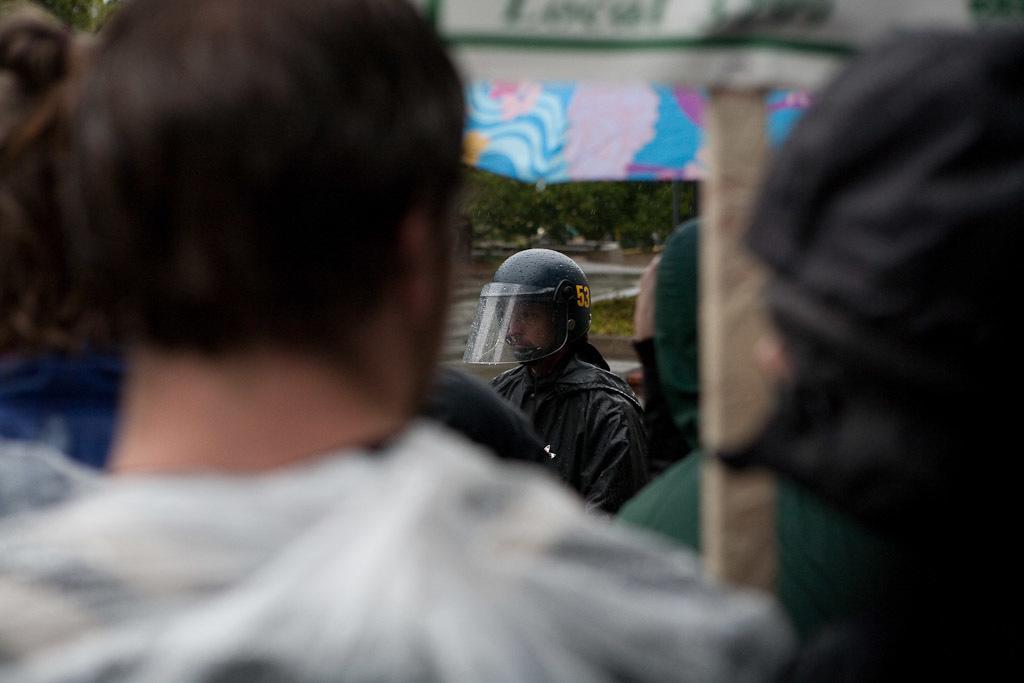In one or two sentences, can you explain what this image depicts? In this image I can see group of people. In front the person is wearing white color shirt, background I can see an umbrella in multi color and I can see trees in green color. 